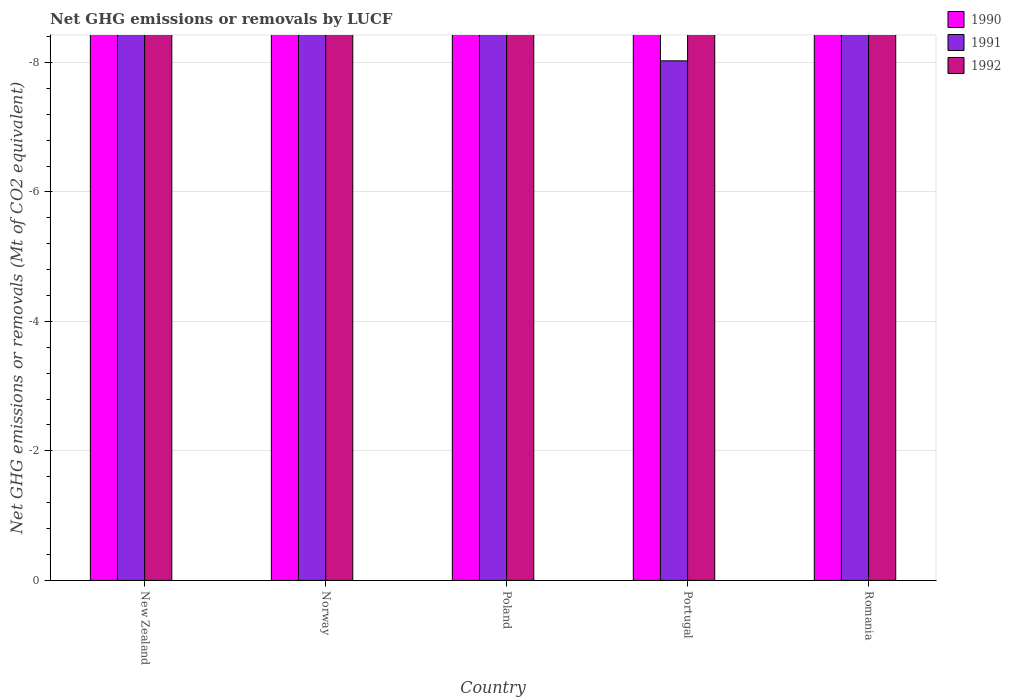How many different coloured bars are there?
Your answer should be very brief. 0. How many bars are there on the 1st tick from the left?
Give a very brief answer. 0. What is the label of the 1st group of bars from the left?
Provide a short and direct response. New Zealand. In how many cases, is the number of bars for a given country not equal to the number of legend labels?
Your answer should be very brief. 5. What is the average net GHG emissions or removals by LUCF in 1992 per country?
Provide a short and direct response. 0. In how many countries, is the net GHG emissions or removals by LUCF in 1992 greater than -3.2 Mt?
Make the answer very short. 0. Is it the case that in every country, the sum of the net GHG emissions or removals by LUCF in 1991 and net GHG emissions or removals by LUCF in 1990 is greater than the net GHG emissions or removals by LUCF in 1992?
Ensure brevity in your answer.  No. How many bars are there?
Keep it short and to the point. 0. Are all the bars in the graph horizontal?
Your answer should be compact. No. How many countries are there in the graph?
Provide a succinct answer. 5. What is the difference between two consecutive major ticks on the Y-axis?
Offer a terse response. 2. Are the values on the major ticks of Y-axis written in scientific E-notation?
Your response must be concise. No. Does the graph contain any zero values?
Provide a short and direct response. Yes. Does the graph contain grids?
Ensure brevity in your answer.  Yes. How many legend labels are there?
Give a very brief answer. 3. How are the legend labels stacked?
Keep it short and to the point. Vertical. What is the title of the graph?
Keep it short and to the point. Net GHG emissions or removals by LUCF. What is the label or title of the X-axis?
Make the answer very short. Country. What is the label or title of the Y-axis?
Your answer should be very brief. Net GHG emissions or removals (Mt of CO2 equivalent). What is the Net GHG emissions or removals (Mt of CO2 equivalent) of 1992 in New Zealand?
Provide a short and direct response. 0. What is the Net GHG emissions or removals (Mt of CO2 equivalent) in 1990 in Norway?
Make the answer very short. 0. What is the Net GHG emissions or removals (Mt of CO2 equivalent) of 1990 in Portugal?
Your answer should be compact. 0. What is the Net GHG emissions or removals (Mt of CO2 equivalent) of 1991 in Portugal?
Your response must be concise. 0. What is the Net GHG emissions or removals (Mt of CO2 equivalent) in 1990 in Romania?
Your response must be concise. 0. What is the Net GHG emissions or removals (Mt of CO2 equivalent) in 1991 in Romania?
Offer a very short reply. 0. What is the average Net GHG emissions or removals (Mt of CO2 equivalent) of 1992 per country?
Make the answer very short. 0. 